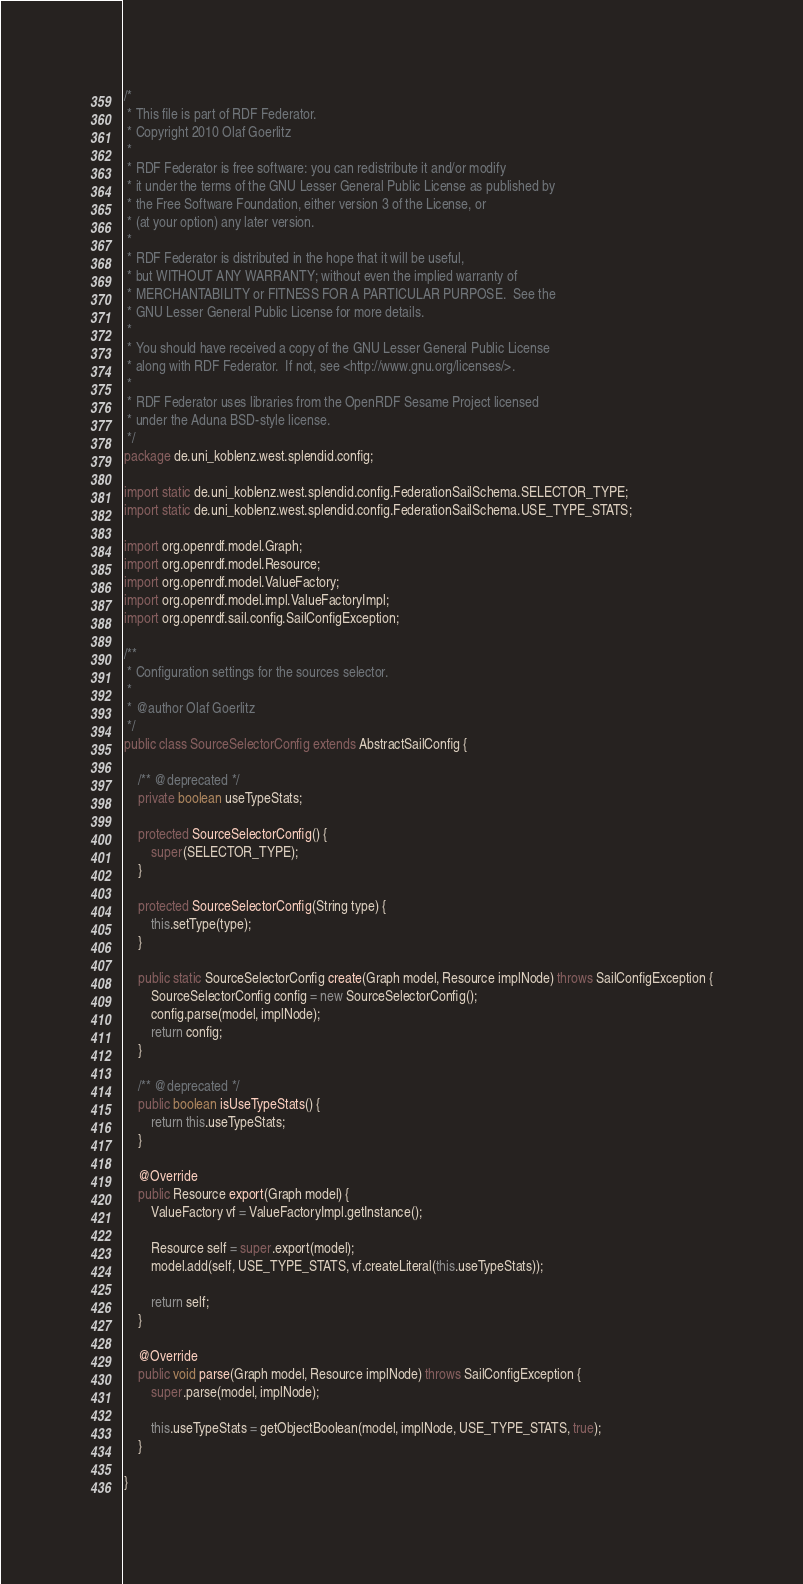Convert code to text. <code><loc_0><loc_0><loc_500><loc_500><_Java_>/*
 * This file is part of RDF Federator.
 * Copyright 2010 Olaf Goerlitz
 * 
 * RDF Federator is free software: you can redistribute it and/or modify
 * it under the terms of the GNU Lesser General Public License as published by
 * the Free Software Foundation, either version 3 of the License, or
 * (at your option) any later version.
 * 
 * RDF Federator is distributed in the hope that it will be useful,
 * but WITHOUT ANY WARRANTY; without even the implied warranty of
 * MERCHANTABILITY or FITNESS FOR A PARTICULAR PURPOSE.  See the
 * GNU Lesser General Public License for more details.
 * 
 * You should have received a copy of the GNU Lesser General Public License
 * along with RDF Federator.  If not, see <http://www.gnu.org/licenses/>.
 * 
 * RDF Federator uses libraries from the OpenRDF Sesame Project licensed 
 * under the Aduna BSD-style license. 
 */
package de.uni_koblenz.west.splendid.config;

import static de.uni_koblenz.west.splendid.config.FederationSailSchema.SELECTOR_TYPE;
import static de.uni_koblenz.west.splendid.config.FederationSailSchema.USE_TYPE_STATS;

import org.openrdf.model.Graph;
import org.openrdf.model.Resource;
import org.openrdf.model.ValueFactory;
import org.openrdf.model.impl.ValueFactoryImpl;
import org.openrdf.sail.config.SailConfigException;

/**
 * Configuration settings for the sources selector.
 * 
 * @author Olaf Goerlitz
 */
public class SourceSelectorConfig extends AbstractSailConfig {
	
	/** @deprecated */
	private boolean useTypeStats;
	
	protected SourceSelectorConfig() {
		super(SELECTOR_TYPE);
	}
	
	protected SourceSelectorConfig(String type) {
		this.setType(type);
	}
	
	public static SourceSelectorConfig create(Graph model, Resource implNode) throws SailConfigException {
		SourceSelectorConfig config = new SourceSelectorConfig();
		config.parse(model, implNode);
		return config;
	}
	
	/** @deprecated */
	public boolean isUseTypeStats() {
		return this.useTypeStats;
	}
	
	@Override
	public Resource export(Graph model) {
		ValueFactory vf = ValueFactoryImpl.getInstance();
		
		Resource self = super.export(model);
		model.add(self, USE_TYPE_STATS, vf.createLiteral(this.useTypeStats));
		
		return self;
	}

	@Override
	public void parse(Graph model, Resource implNode) throws SailConfigException {
		super.parse(model, implNode);
		
		this.useTypeStats = getObjectBoolean(model, implNode, USE_TYPE_STATS, true);
	}

}
</code> 